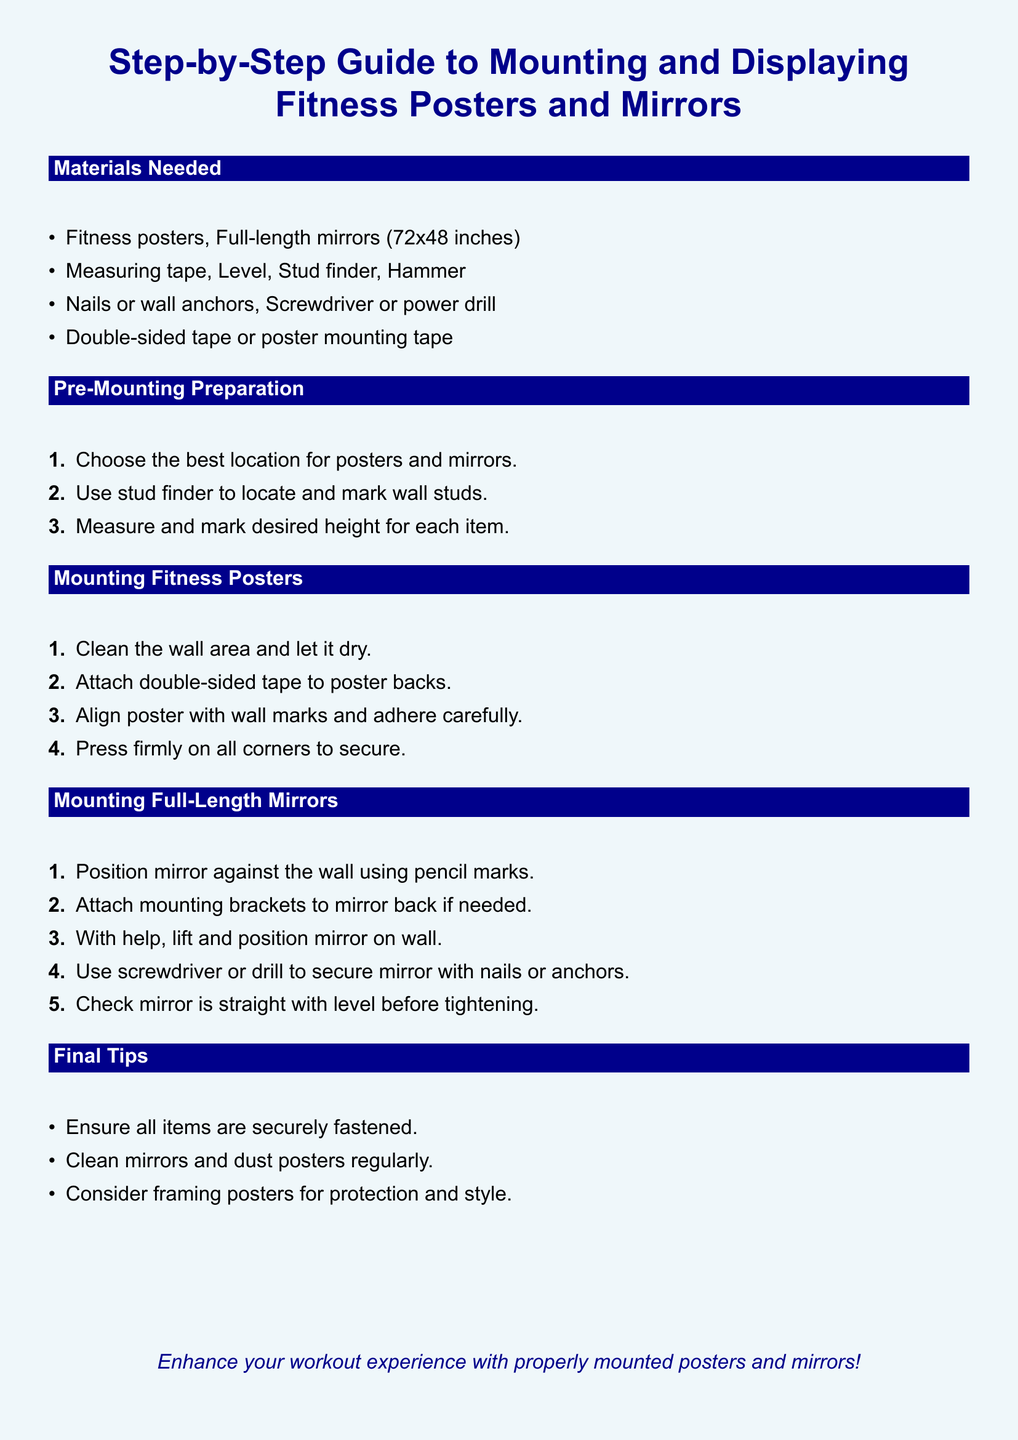What is the size of the full-length mirrors? The document specifies the dimensions for the mirrors as 72x48 inches.
Answer: 72x48 inches What tools are required for mounting mirrors? The document lists necessary tools, specifically mentioning a screwdriver or power drill.
Answer: Screwdriver or power drill How many steps are in the mounting fitness posters section? The document outlines four steps in the section dedicated to mounting fitness posters.
Answer: Four What is the first action in the pre-mounting preparation? The first step requires selecting the best location for posters and mirrors.
Answer: Choose location What should be used to secure the full-length mirrors? The document states that nails or wall anchors are used to secure the mirrors.
Answer: Nails or wall anchors What should be done with the wall area before mounting the poster? The instructions indicate that the wall area should be cleaned and dried prior to mounting the poster.
Answer: Clean and dry Why might you consider framing posters? The final tips suggest that framing can provide protection and style for the posters.
Answer: Protection and style What should be regularly cleaned regarding the fitness posters? The document advises to clean the posters regularly to maintain their appearance.
Answer: Dust posters 